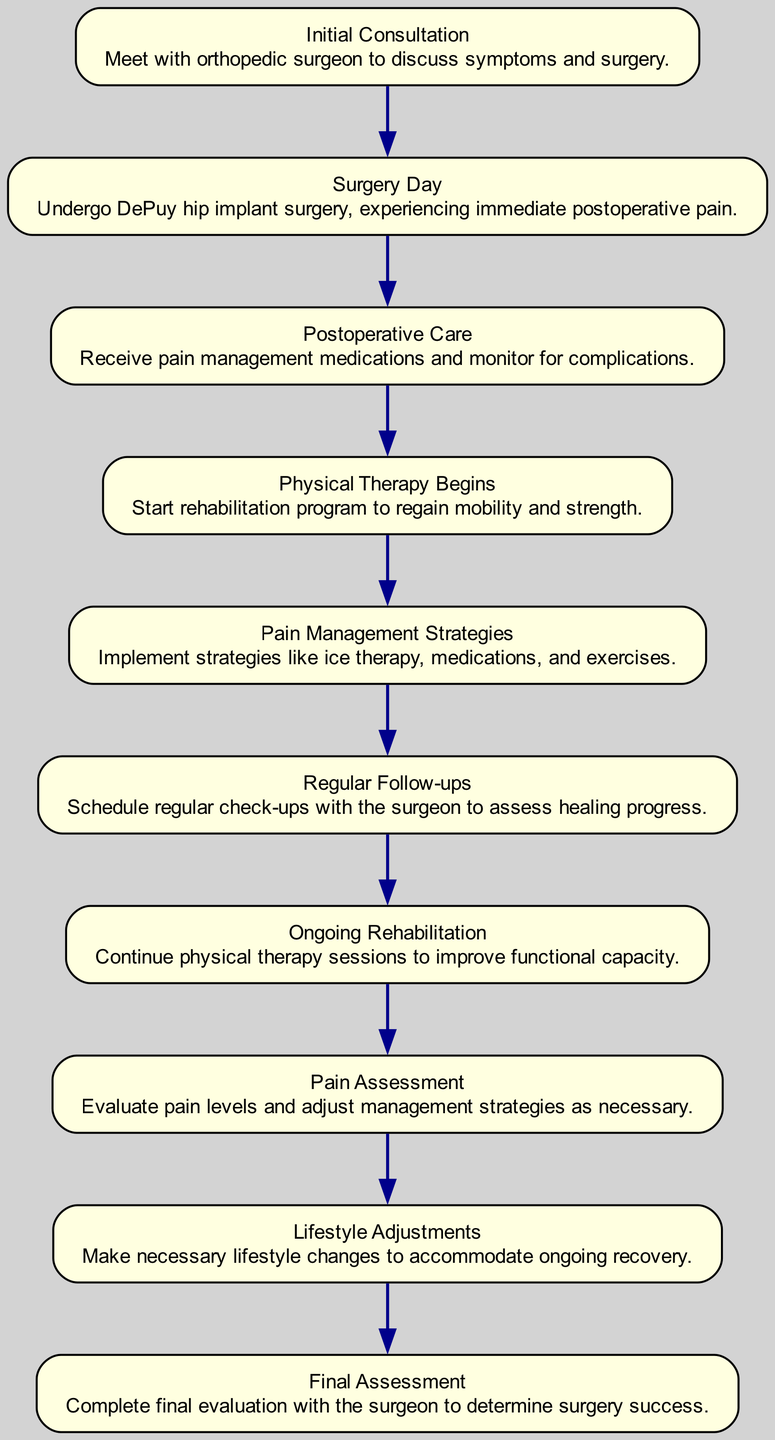What is the first step in the journey? The first step in the journey is depicted as "Initial Consultation." This information is found at the top of the flowchart and is the first node in the sequence.
Answer: Initial Consultation What follows after "Postoperative Care"? According to the flowchart, immediately following "Postoperative Care," the next step is "Physical Therapy Begins." This is determined by looking at the flow connections which show the order of events.
Answer: Physical Therapy Begins How many total nodes are in the diagram? The diagram lists a total of ten distinct steps in the journey, each represented as a separate node, from the initial consultation to the final assessment.
Answer: 10 What is the main purpose of the "Pain Assessment"? The “Pain Assessment” node focuses on evaluating pain levels, which means its primary purpose is to assess and adjust management strategies for pain relief effectively. This is explicitly outlined in the description of that node.
Answer: Evaluate pain levels Which step includes lifestyle changes? The step labeled “Lifestyle Adjustments” specifically addresses making necessary lifestyle changes for recovery. This can be identified directly from the node dedicated to this part of the journey.
Answer: Lifestyle Adjustments What are "Pain Management Strategies" focused on? The "Pain Management Strategies" step is intended to implement various techniques for pain relief, including ice therapy and exercises, as indicated by the description within that node.
Answer: Implement strategies What is the last node in the journey? The final node in the journey is "Final Assessment," which concludes the flow by determining the overall success of the surgery. This can be identified as the last step based on the flowchart structure.
Answer: Final Assessment How does "Ongoing Rehabilitation" relate to "Physical Therapy Begins"? "Ongoing Rehabilitation" is a follow-up step that builds upon the initial “Physical Therapy Begins,” indicating that it represents the continuation or progression of therapy sessions to improve functional capacity, thus showing a direct relationship in the sequence of recovery steps.
Answer: Continuation of therapy sessions What type of follow-up is indicated throughout the process? The diagram denotes “Regular Follow-ups” as check-ups with the surgeon to monitor the healing progress, indicating ongoing interaction and assessment during the recovery journey.
Answer: Regular check-ups 